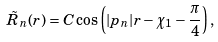Convert formula to latex. <formula><loc_0><loc_0><loc_500><loc_500>\tilde { R } _ { n } ( r ) = C \cos \left ( | p _ { n } | r - \chi _ { 1 } - \frac { \pi } 4 \right ) ,</formula> 